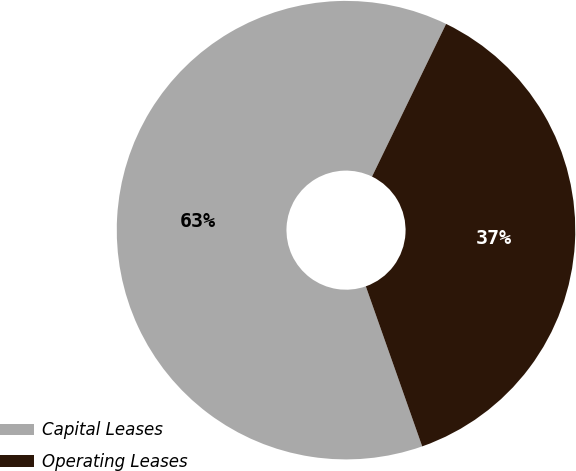Convert chart. <chart><loc_0><loc_0><loc_500><loc_500><pie_chart><fcel>Capital Leases<fcel>Operating Leases<nl><fcel>62.58%<fcel>37.42%<nl></chart> 